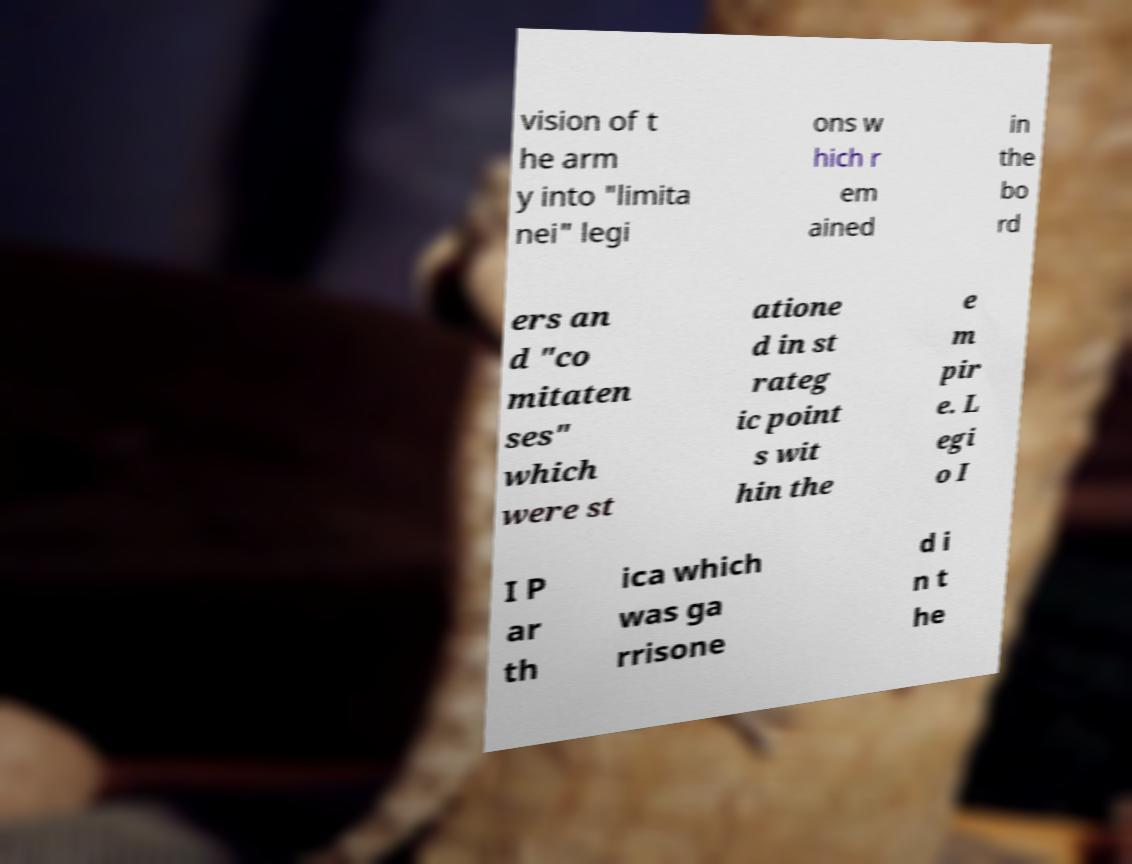Can you accurately transcribe the text from the provided image for me? vision of t he arm y into "limita nei" legi ons w hich r em ained in the bo rd ers an d "co mitaten ses" which were st atione d in st rateg ic point s wit hin the e m pir e. L egi o I I P ar th ica which was ga rrisone d i n t he 